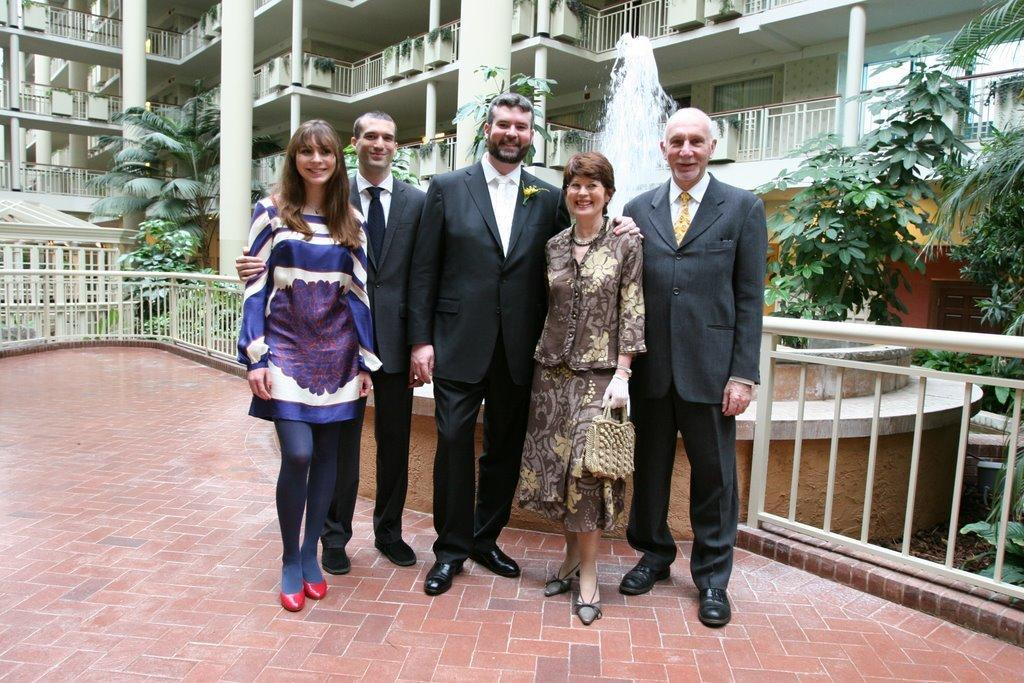What are the people in the image doing? The persons standing in the center of the image are smiling. What can be seen in the background of the image? There is a building, pillars, and trees in the background of the image. What is present in the center of the image besides the people? There is a fence in the center of the image. How much profit did the persons in the image make from selling the rings? There is no mention of rings or profit in the image, so it is not possible to answer that question. 